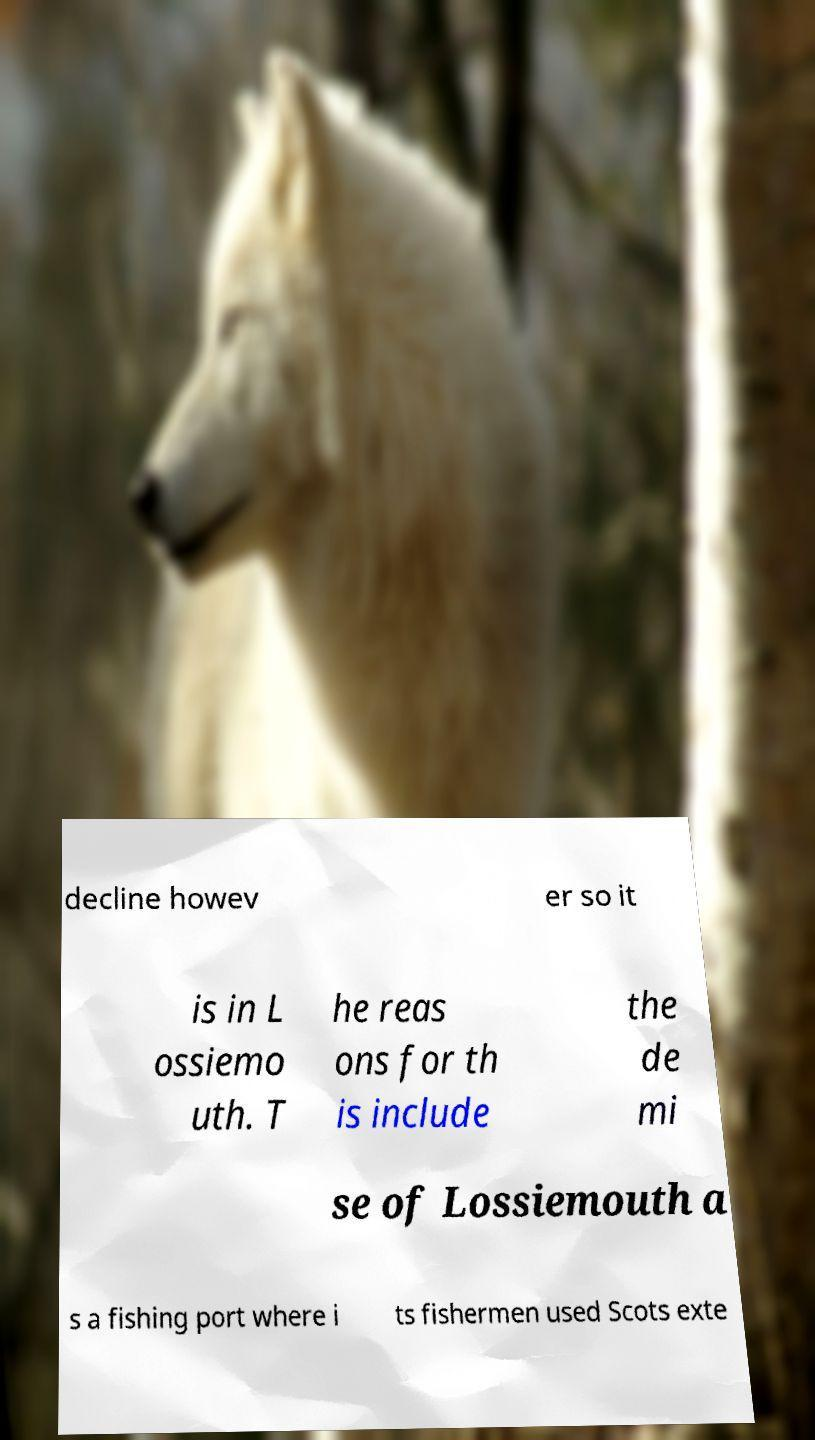I need the written content from this picture converted into text. Can you do that? decline howev er so it is in L ossiemo uth. T he reas ons for th is include the de mi se of Lossiemouth a s a fishing port where i ts fishermen used Scots exte 